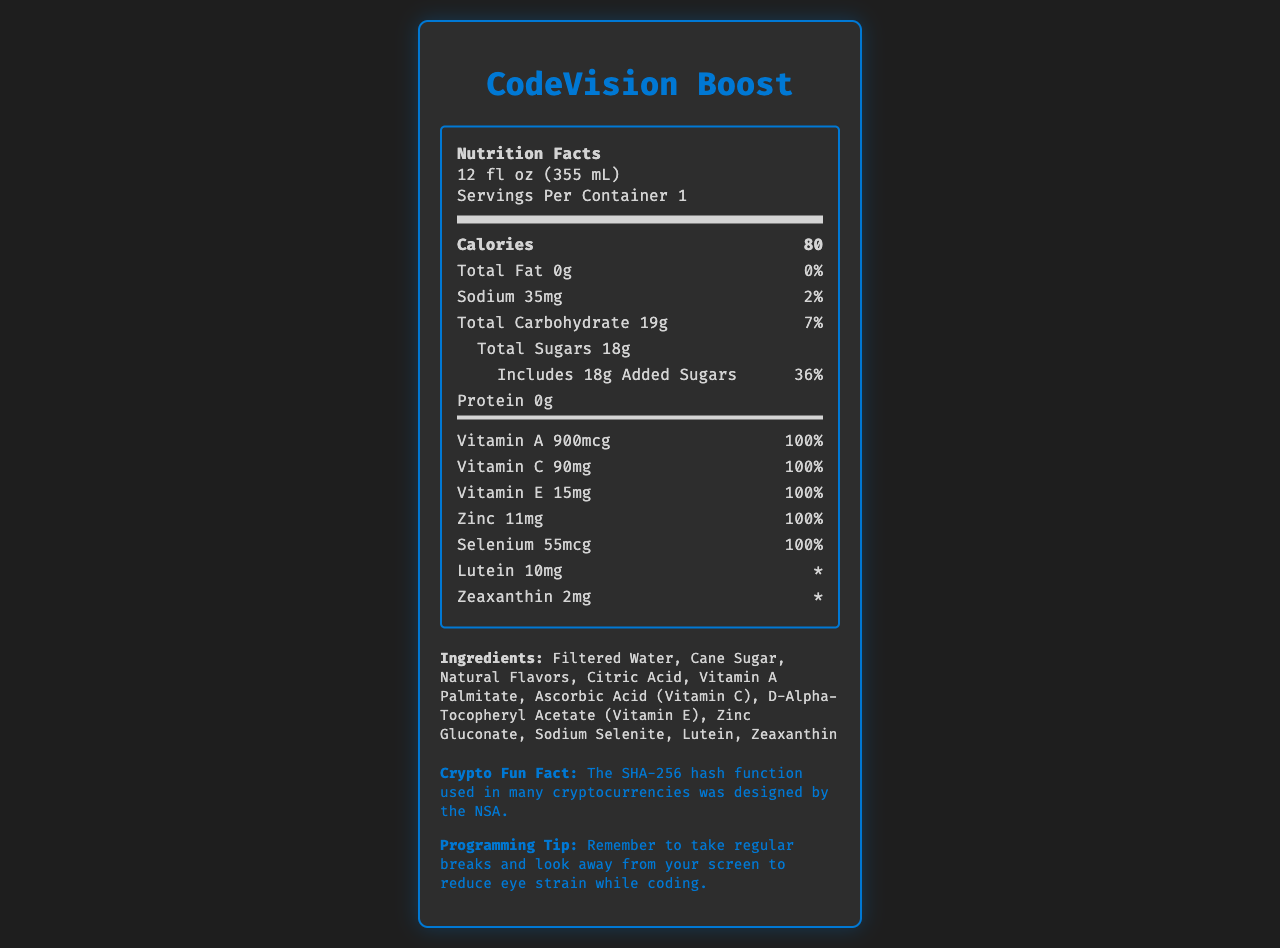what is the serving size of CodeVision Boost? The serving size is listed as "12 fl oz (355 mL)" on the document.
Answer: 12 fl oz (355 mL) how many calories are in one serving? The document states that there are 80 calories per serving.
Answer: 80 calories what percentage of the daily value of added sugars does one serving of CodeVision Boost contain? The label indicates that one serving includes 18g of added sugars, which is equivalent to 36% of the daily value.
Answer: 36% how much sodium is in one serving? The document lists the sodium content as 35mg per serving.
Answer: 35mg List the vitamins and minerals that have 100% daily value per serving. Each of these vitamins and minerals is indicated to have a daily value of 100%.
Answer: Vitamin A, Vitamin C, Vitamin E, Zinc, Selenium which ingredient is listed first? Ingredients are listed in order of quantity, and "Filtered Water" is the first item in the ingredient list.
Answer: Filtered Water what is the special feature of the beverage related to coding? One of the special features mentioned is that the beverage supports eye health during long coding sessions.
Answer: Supports eye health during long coding sessions how much Lutein is in one serving? The document states that there is 10mg of Lutein per serving.
Answer: 10mg what should programmers remember to do to reduce eye strain while coding? The programming tip advises programmers to take regular breaks and look away from the screen to reduce eye strain.
Answer: Take regular breaks and look away from the screen codevision boost contains which allergens? A. Dairy B. Gluten C. No known allergens The allergen information indicates that the product contains no known allergens.
Answer: C which of the following is not a vitamin found in CodeVision Boost? A. Vitamin D B. Vitamin A C. Vitamin C D. Vitamin E Vitamin D is not listed among the vitamins in CodeVision Boost.
Answer: A does CodeVision Boost contain artificial colors or preservatives? One of the special features mentioned is "No artificial colors or preservatives."
Answer: No is CodeVision Boost caffeine-free? The document lists "Caffeine-free" under special features.
Answer: Yes what is the main idea of the CodeVision Boost Nutrition Facts Label? The document provides detailed nutrition facts, ingredients, special features, and additional tips related to product use for programmers.
Answer: CodeVision Boost is a vitamin-fortified beverage designed to support eye health, especially for programmers during long coding sessions. It contains essential vitamins and minerals with notable amounts of Vitamin A, C, E, Zinc, and Selenium, and features like no artificial colors or preservatives and caffeine-free. how much protein is in one serving of CodeVision Boost? The document lists the protein content as 0g per serving.
Answer: 0g what is the sodium daily value percentage in one container? The document states that the sodium content of 35mg represents 2% of the daily value.
Answer: 2% is it possible to determine the price of CodeVision Boost from the document? The document does not provide any information regarding the price of CodeVision Boost, so it cannot be determined.
Answer: Not enough information 